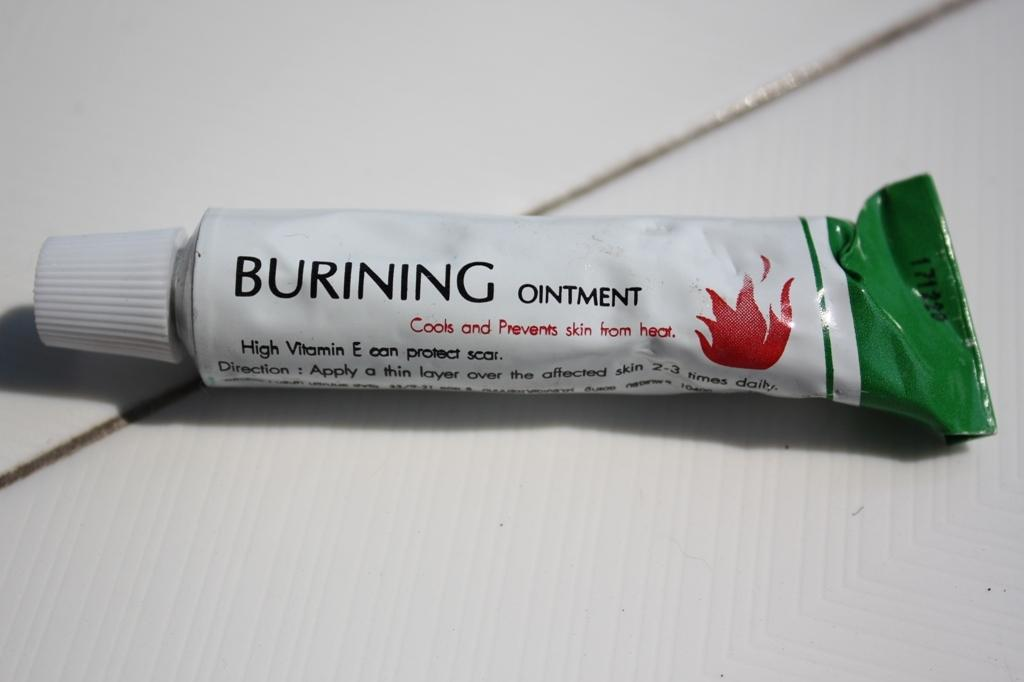<image>
Relay a brief, clear account of the picture shown. A mostly white with a green tip ointment meant for burns. 